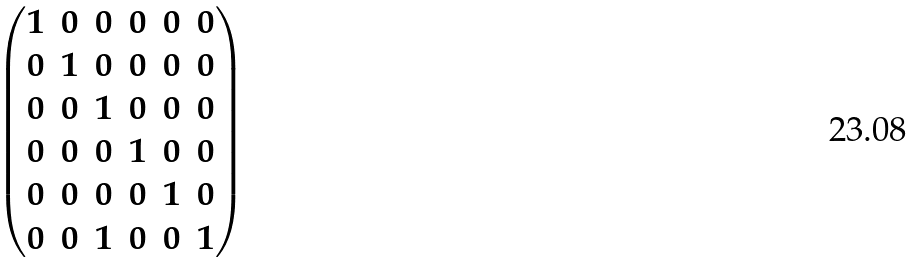<formula> <loc_0><loc_0><loc_500><loc_500>\begin{pmatrix} 1 & 0 & 0 & 0 & 0 & 0 \\ 0 & 1 & 0 & 0 & 0 & 0 \\ 0 & 0 & 1 & 0 & 0 & 0 \\ 0 & 0 & 0 & 1 & 0 & 0 \\ 0 & 0 & 0 & 0 & 1 & 0 \\ 0 & 0 & 1 & 0 & 0 & 1 \\ \end{pmatrix}</formula> 